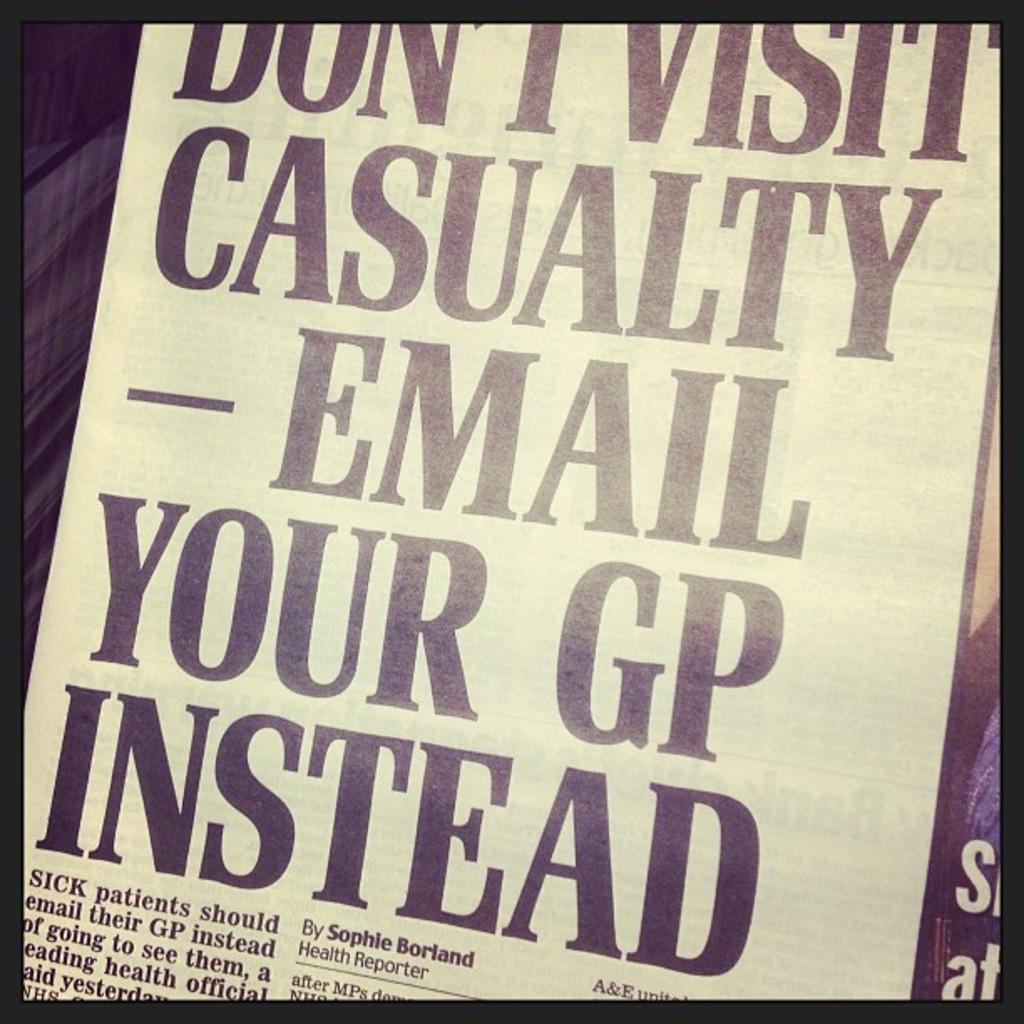Don't visit what?
Ensure brevity in your answer.  Casualty. What should you do with your gp?
Ensure brevity in your answer.  Email. 